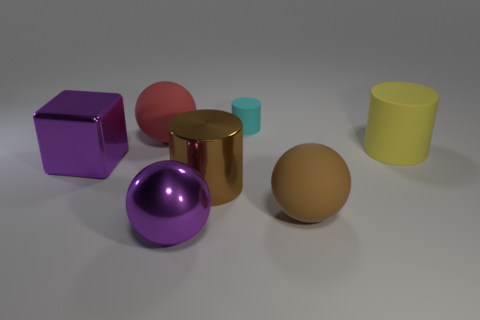The shiny thing that is the same color as the shiny sphere is what shape?
Your response must be concise. Cube. What number of purple objects are either big spheres or shiny cubes?
Give a very brief answer. 2. The brown rubber sphere is what size?
Ensure brevity in your answer.  Large. Are there more cyan rubber cylinders left of the small cyan rubber cylinder than large red rubber balls?
Make the answer very short. No. There is a big metal ball; how many brown cylinders are left of it?
Offer a terse response. 0. Is there another matte cylinder of the same size as the brown cylinder?
Offer a terse response. Yes. What color is the other large object that is the same shape as the big brown metal object?
Your answer should be very brief. Yellow. There is a purple thing behind the purple sphere; is it the same size as the rubber cylinder behind the yellow thing?
Your answer should be compact. No. Are there any other cyan matte things of the same shape as the small cyan matte thing?
Provide a short and direct response. No. Are there an equal number of cyan rubber objects to the right of the big yellow thing and large green metallic blocks?
Your response must be concise. Yes. 